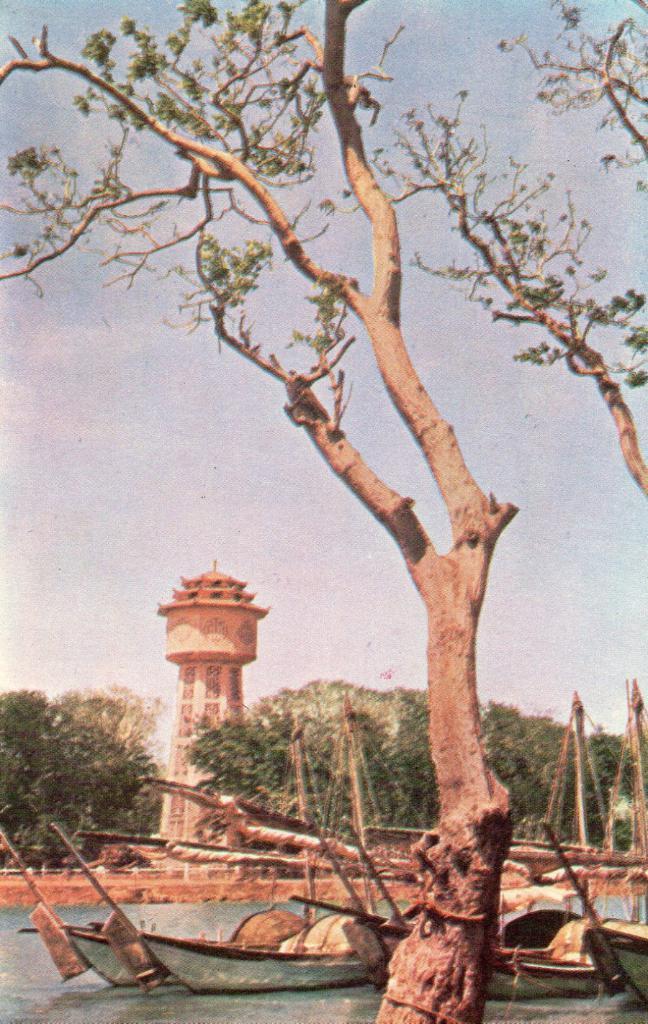Can you describe this image briefly? In this picture I can see the boats on the water, in the middle there are trees and it looks like a pillar. At the top I can see the sky. 